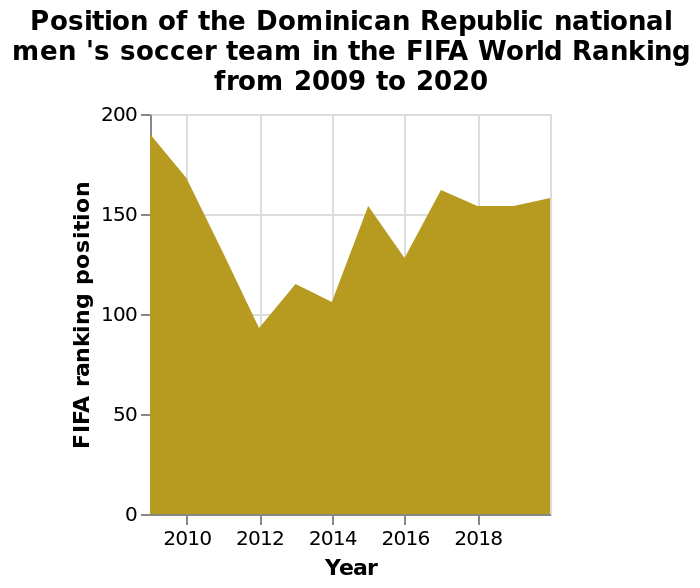<image>
What was the ranking of the Dominican Republic national men's soccer team from 2016 to 2018? The ranking of the Dominican Republic national men's soccer team stabilized at 150 from 2016 to 2018. Has the ranking of the Dominican Republic national men's soccer team remained above 100 since 2012? No, the ranking of the Dominican Republic national men's soccer team dropped back to beyond 100 since then. 